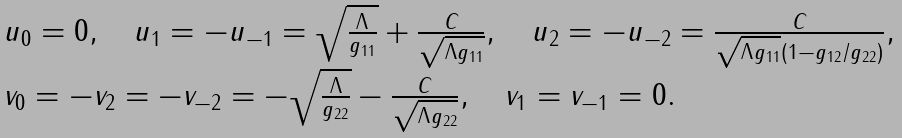Convert formula to latex. <formula><loc_0><loc_0><loc_500><loc_500>\begin{array} { l l l } & & u _ { 0 } = 0 , \quad u _ { 1 } = - u _ { - 1 } = \sqrt { \frac { \Lambda } { g _ { 1 1 } } } + \frac { C } { \sqrt { \Lambda g _ { 1 1 } } } , \quad u _ { 2 } = - u _ { - 2 } = \frac { C } { \sqrt { \Lambda g _ { 1 1 } } ( 1 - g _ { 1 2 } / g _ { 2 2 } ) } , \\ & & v _ { 0 } = - v _ { 2 } = - v _ { - 2 } = - \sqrt { \frac { \Lambda } { g _ { 2 2 } } } - \frac { C } { \sqrt { \Lambda g _ { 2 2 } } } , \quad v _ { 1 } = v _ { - 1 } = 0 . \end{array}</formula> 